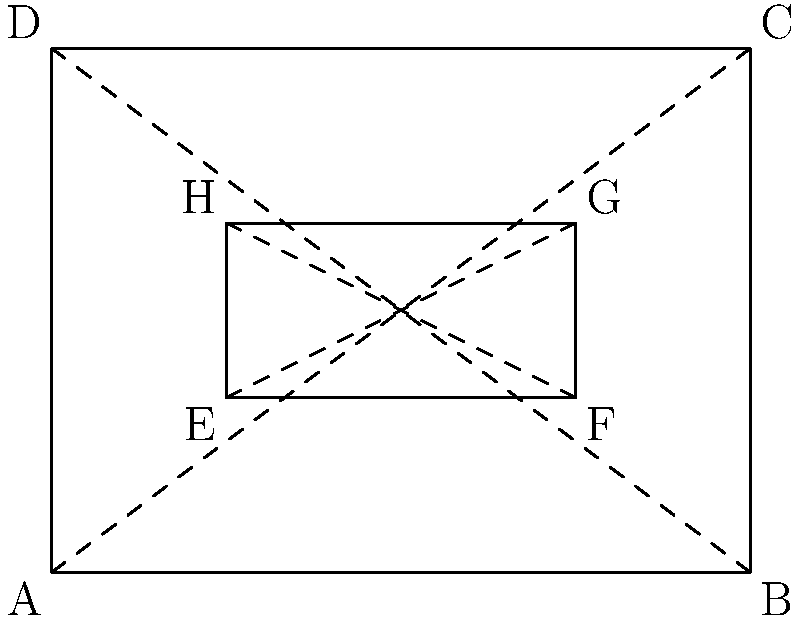In applying a specialized wound dressing, a trauma surgeon needs to cover two congruent rectangular areas on a patient's body. The larger rectangle ABCD represents the total area of the dressing, while the smaller rectangle EFGH represents the actual wound area. If the diagonal AC of the larger rectangle is 5 units long, and the diagonal EG of the smaller rectangle is 2.5 units long, what is the ratio of the area of the wound (EFGH) to the total dressing area (ABCD)? Let's approach this step-by-step:

1) For a rectangle, we can use the Pythagorean theorem to relate the diagonal to the sides.

2) For rectangle ABCD:
   $AC^2 = AB^2 + AD^2$
   $5^2 = AB^2 + AD^2$
   $25 = AB^2 + AD^2$

3) For rectangle EFGH:
   $EG^2 = EF^2 + EH^2$
   $2.5^2 = EF^2 + EH^2$
   $6.25 = EF^2 + EH^2$

4) Notice that the diagonals are in a 2:1 ratio (5:2.5). In similar rectangles, all linear dimensions are in the same ratio.

5) This means that the sides of EFGH are half the length of the corresponding sides of ABCD.

6) The area of a rectangle is length * width. So:
   Area of ABCD = AB * AD
   Area of EFGH = EF * EH = (AB/2) * (AD/2) = (AB * AD) / 4

7) Therefore, the area of EFGH is 1/4 of the area of ABCD.

8) The ratio of the area of EFGH to ABCD is thus 1:4 or 1/4.
Answer: 1:4 